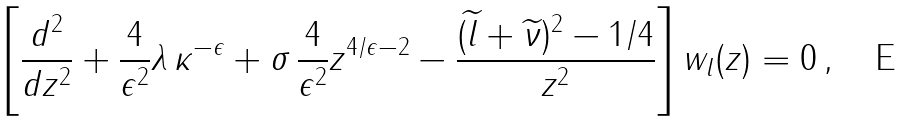Convert formula to latex. <formula><loc_0><loc_0><loc_500><loc_500>\left [ \frac { d ^ { 2 } } { d z ^ { 2 } } + \frac { 4 } { \epsilon ^ { 2 } } \lambda \, \kappa ^ { - \epsilon } + \sigma \, \frac { 4 } { \epsilon ^ { 2 } } z ^ { 4 / \epsilon - 2 } - \frac { ( \widetilde { l } + \widetilde { \nu } ) ^ { 2 } - 1 / 4 } { z ^ { 2 } } \right ] w _ { l } ( z ) = 0 \, ,</formula> 